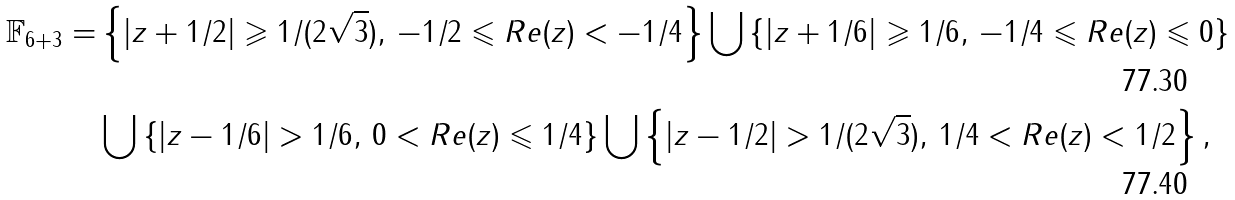Convert formula to latex. <formula><loc_0><loc_0><loc_500><loc_500>\mathbb { F } _ { 6 + 3 } = & \left \{ | z + 1 / 2 | \geqslant 1 / ( 2 \sqrt { 3 } ) , \, - 1 / 2 \leqslant R e ( z ) < - 1 / 4 \right \} \bigcup \left \{ | z + 1 / 6 | \geqslant 1 / 6 , \, - 1 / 4 \leqslant R e ( z ) \leqslant 0 \right \} \\ & \bigcup \left \{ | z - 1 / 6 | > 1 / 6 , \, 0 < R e ( z ) \leqslant 1 / 4 \right \} \bigcup \left \{ | z - 1 / 2 | > 1 / ( 2 \sqrt { 3 } ) , \, 1 / 4 < R e ( z ) < 1 / 2 \right \} ,</formula> 